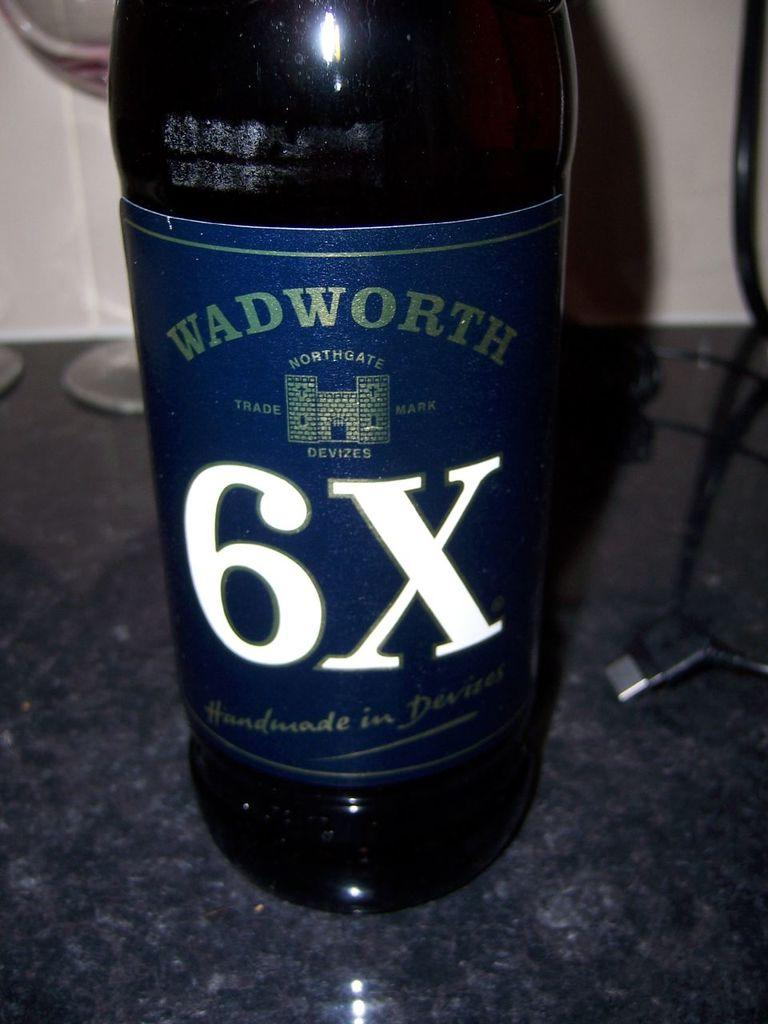<image>
Offer a succinct explanation of the picture presented. A bottle of Wadworth 6X beer, which claims to be handmade in Devizes. 